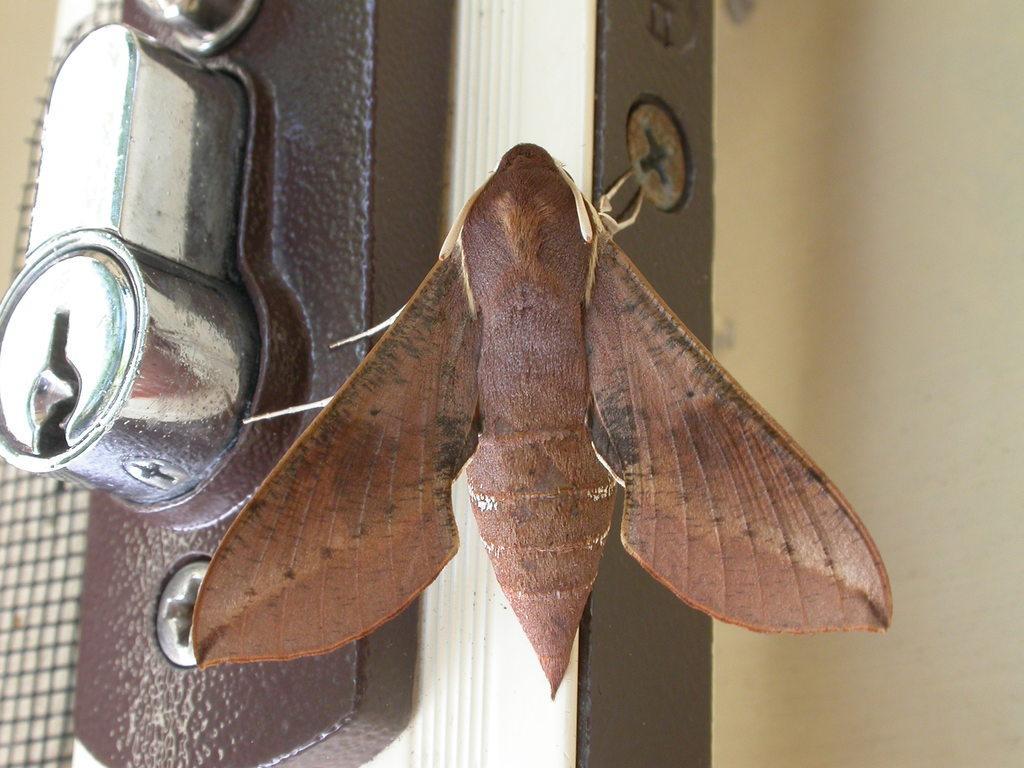In one or two sentences, can you explain what this image depicts? This is a zoomed in picture. In the center there is a moth seems to be standing on the door. In the left we can see the keyhole. In the background there is a wall. 